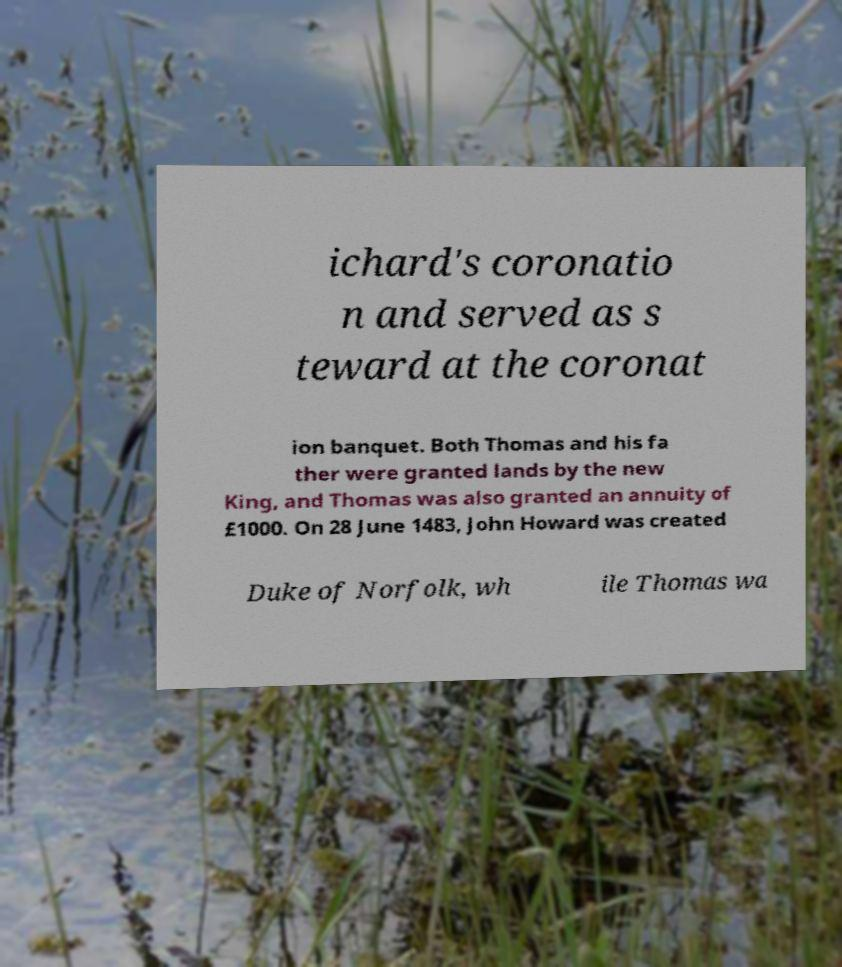Can you read and provide the text displayed in the image?This photo seems to have some interesting text. Can you extract and type it out for me? ichard's coronatio n and served as s teward at the coronat ion banquet. Both Thomas and his fa ther were granted lands by the new King, and Thomas was also granted an annuity of £1000. On 28 June 1483, John Howard was created Duke of Norfolk, wh ile Thomas wa 